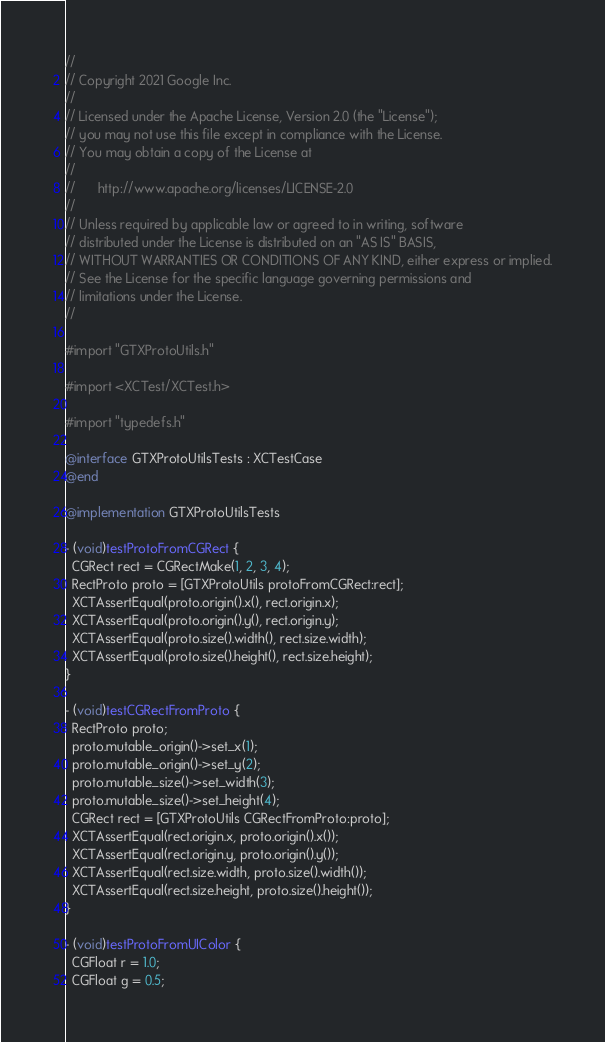Convert code to text. <code><loc_0><loc_0><loc_500><loc_500><_ObjectiveC_>//
// Copyright 2021 Google Inc.
//
// Licensed under the Apache License, Version 2.0 (the "License");
// you may not use this file except in compliance with the License.
// You may obtain a copy of the License at
//
//      http://www.apache.org/licenses/LICENSE-2.0
//
// Unless required by applicable law or agreed to in writing, software
// distributed under the License is distributed on an "AS IS" BASIS,
// WITHOUT WARRANTIES OR CONDITIONS OF ANY KIND, either express or implied.
// See the License for the specific language governing permissions and
// limitations under the License.
//

#import "GTXProtoUtils.h"

#import <XCTest/XCTest.h>

#import "typedefs.h"

@interface GTXProtoUtilsTests : XCTestCase
@end

@implementation GTXProtoUtilsTests

- (void)testProtoFromCGRect {
  CGRect rect = CGRectMake(1, 2, 3, 4);
  RectProto proto = [GTXProtoUtils protoFromCGRect:rect];
  XCTAssertEqual(proto.origin().x(), rect.origin.x);
  XCTAssertEqual(proto.origin().y(), rect.origin.y);
  XCTAssertEqual(proto.size().width(), rect.size.width);
  XCTAssertEqual(proto.size().height(), rect.size.height);
}

- (void)testCGRectFromProto {
  RectProto proto;
  proto.mutable_origin()->set_x(1);
  proto.mutable_origin()->set_y(2);
  proto.mutable_size()->set_width(3);
  proto.mutable_size()->set_height(4);
  CGRect rect = [GTXProtoUtils CGRectFromProto:proto];
  XCTAssertEqual(rect.origin.x, proto.origin().x());
  XCTAssertEqual(rect.origin.y, proto.origin().y());
  XCTAssertEqual(rect.size.width, proto.size().width());
  XCTAssertEqual(rect.size.height, proto.size().height());
}

- (void)testProtoFromUIColor {
  CGFloat r = 1.0;
  CGFloat g = 0.5;</code> 